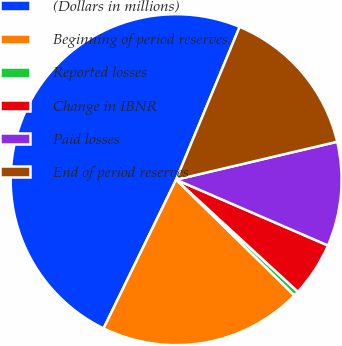Convert chart. <chart><loc_0><loc_0><loc_500><loc_500><pie_chart><fcel>(Dollars in millions)<fcel>Beginning of period reserves<fcel>Reported losses<fcel>Change in IBNR<fcel>Paid losses<fcel>End of period reserves<nl><fcel>49.04%<fcel>19.9%<fcel>0.48%<fcel>5.33%<fcel>10.19%<fcel>15.05%<nl></chart> 